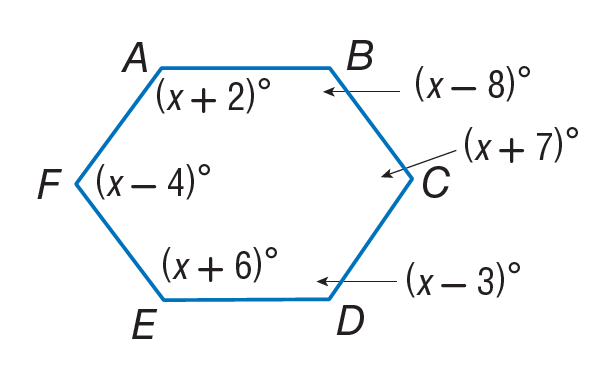Answer the mathemtical geometry problem and directly provide the correct option letter.
Question: Find m \angle F.
Choices: A: 100 B: 116 C: 127 D: 140 B 